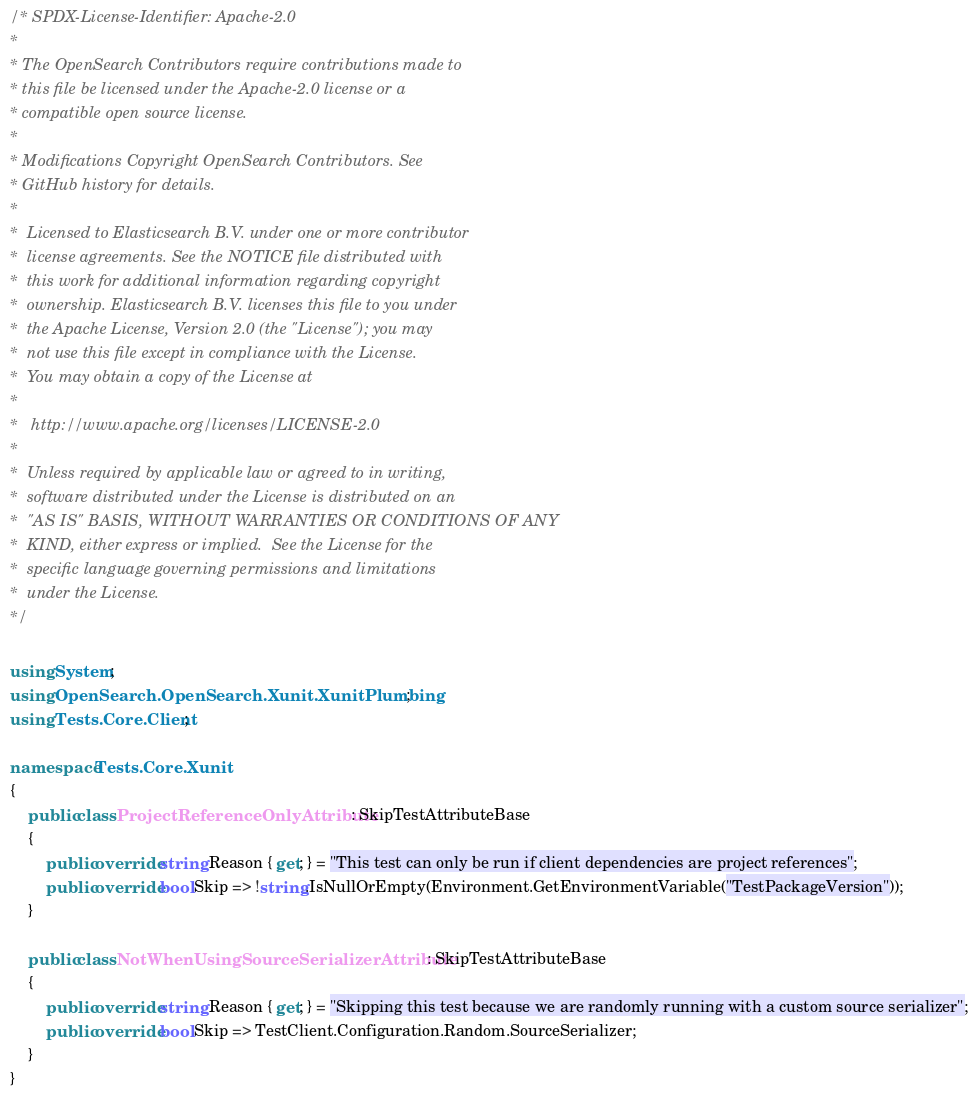<code> <loc_0><loc_0><loc_500><loc_500><_C#_>/* SPDX-License-Identifier: Apache-2.0
*
* The OpenSearch Contributors require contributions made to
* this file be licensed under the Apache-2.0 license or a
* compatible open source license.
*
* Modifications Copyright OpenSearch Contributors. See
* GitHub history for details.
*
*  Licensed to Elasticsearch B.V. under one or more contributor
*  license agreements. See the NOTICE file distributed with
*  this work for additional information regarding copyright
*  ownership. Elasticsearch B.V. licenses this file to you under
*  the Apache License, Version 2.0 (the "License"); you may
*  not use this file except in compliance with the License.
*  You may obtain a copy of the License at
*
* 	http://www.apache.org/licenses/LICENSE-2.0
*
*  Unless required by applicable law or agreed to in writing,
*  software distributed under the License is distributed on an
*  "AS IS" BASIS, WITHOUT WARRANTIES OR CONDITIONS OF ANY
*  KIND, either express or implied.  See the License for the
*  specific language governing permissions and limitations
*  under the License.
*/

using System;
using OpenSearch.OpenSearch.Xunit.XunitPlumbing;
using Tests.Core.Client;

namespace Tests.Core.Xunit
{
	public class ProjectReferenceOnlyAttribute : SkipTestAttributeBase
	{
		public override string Reason { get; } = "This test can only be run if client dependencies are project references";
		public override bool Skip => !string.IsNullOrEmpty(Environment.GetEnvironmentVariable("TestPackageVersion"));
	}

	public class NotWhenUsingSourceSerializerAttribute : SkipTestAttributeBase
	{
		public override string Reason { get; } = "Skipping this test because we are randomly running with a custom source serializer";
		public override bool Skip => TestClient.Configuration.Random.SourceSerializer;
	}
}
</code> 